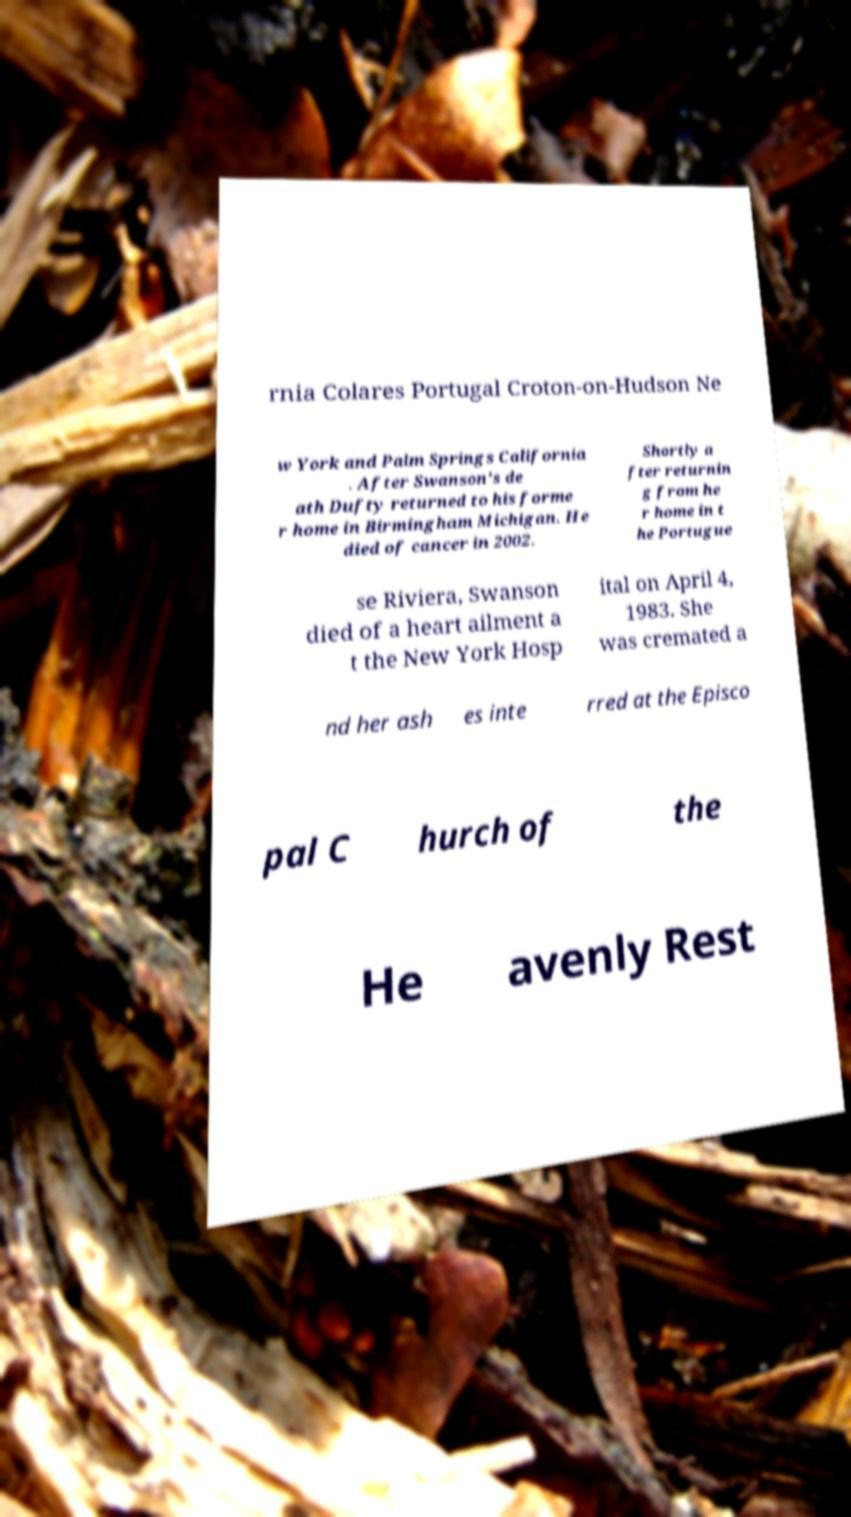Could you extract and type out the text from this image? rnia Colares Portugal Croton-on-Hudson Ne w York and Palm Springs California . After Swanson's de ath Dufty returned to his forme r home in Birmingham Michigan. He died of cancer in 2002. Shortly a fter returnin g from he r home in t he Portugue se Riviera, Swanson died of a heart ailment a t the New York Hosp ital on April 4, 1983. She was cremated a nd her ash es inte rred at the Episco pal C hurch of the He avenly Rest 